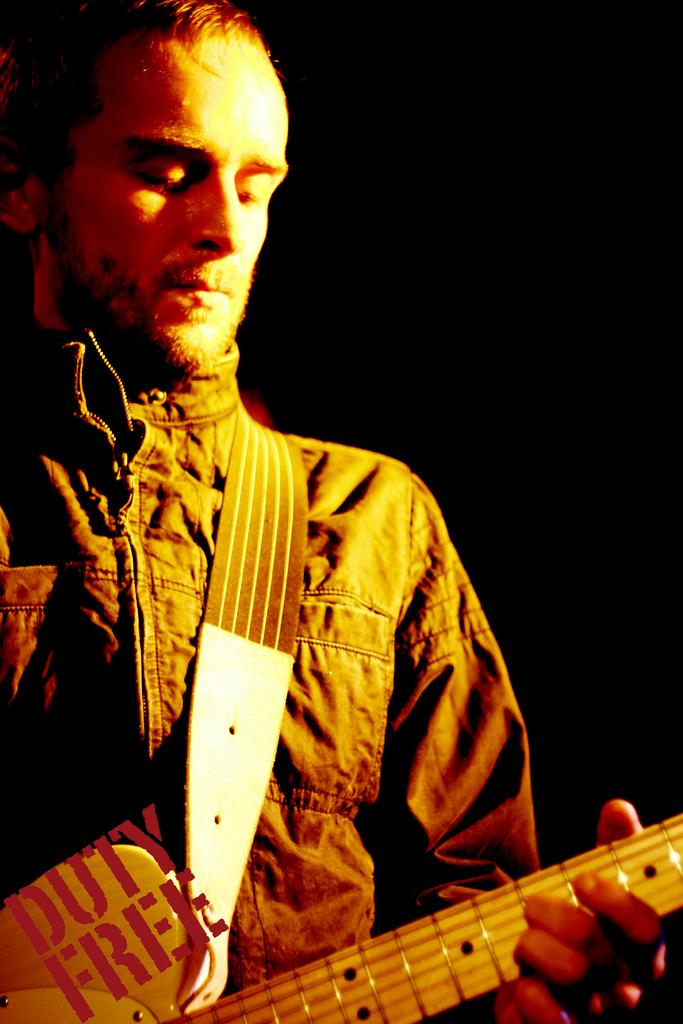What is the main subject of the image? There is a man in the image. What is the man doing in the image? The man is playing a guitar. How many jellyfish can be seen swimming in the background of the image? There are no jellyfish present in the image; it features a man playing a guitar. What force is being applied by the man to the guitar in the image? The image does not provide information about the force being applied by the man to the guitar, only that he is playing it. 